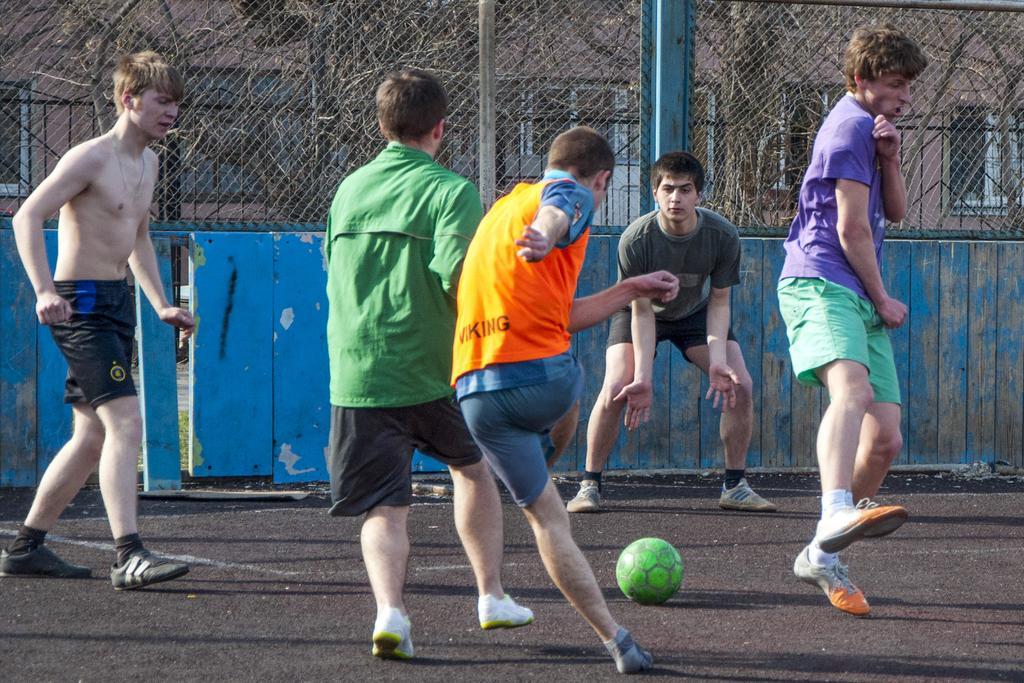What sport are the men playing in the image? The men are playing football in the image. Where is the football being played? The football is being played on the ground. What can be seen in the background of the image? There is wooden fencing, trees, and buildings visible in the background of the image. What type of appliance is being used to cook the stew in the image? There is no appliance or stew present in the image; it features men playing football on the ground. 